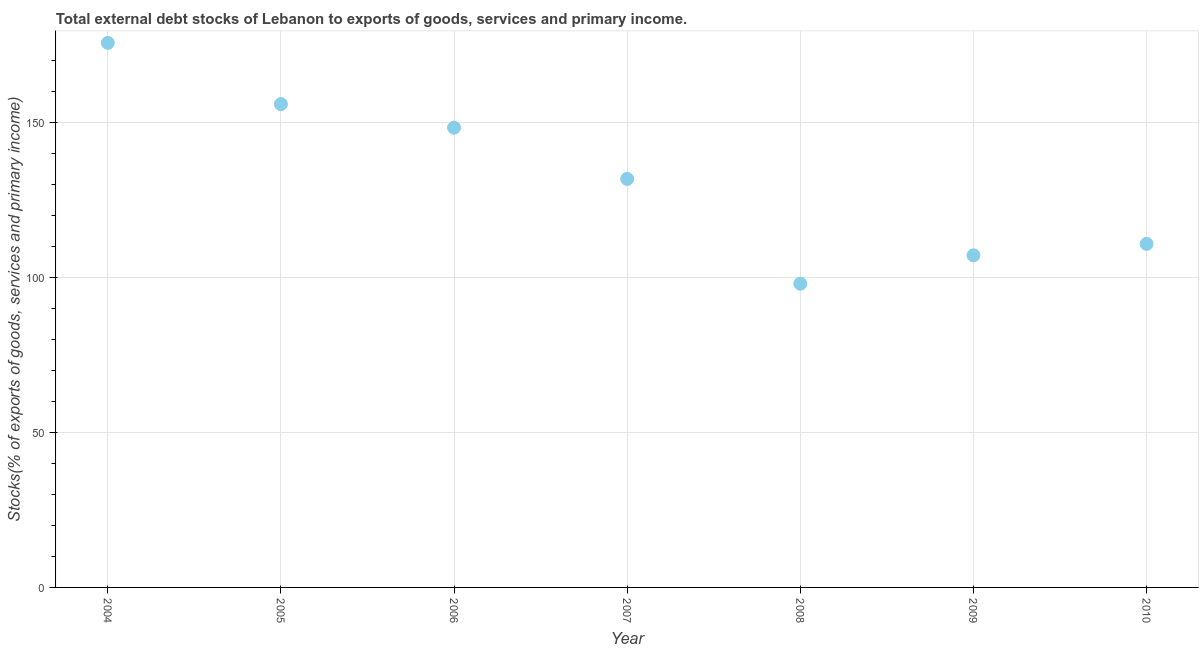What is the external debt stocks in 2007?
Your answer should be compact. 131.87. Across all years, what is the maximum external debt stocks?
Your answer should be very brief. 175.78. Across all years, what is the minimum external debt stocks?
Make the answer very short. 98.05. What is the sum of the external debt stocks?
Offer a terse response. 928.18. What is the difference between the external debt stocks in 2004 and 2010?
Keep it short and to the point. 64.89. What is the average external debt stocks per year?
Give a very brief answer. 132.6. What is the median external debt stocks?
Offer a terse response. 131.87. In how many years, is the external debt stocks greater than 90 %?
Provide a short and direct response. 7. Do a majority of the years between 2005 and 2004 (inclusive) have external debt stocks greater than 70 %?
Provide a short and direct response. No. What is the ratio of the external debt stocks in 2005 to that in 2007?
Give a very brief answer. 1.18. Is the external debt stocks in 2004 less than that in 2009?
Ensure brevity in your answer.  No. Is the difference between the external debt stocks in 2004 and 2007 greater than the difference between any two years?
Provide a succinct answer. No. What is the difference between the highest and the second highest external debt stocks?
Your answer should be compact. 19.78. What is the difference between the highest and the lowest external debt stocks?
Your answer should be very brief. 77.73. In how many years, is the external debt stocks greater than the average external debt stocks taken over all years?
Offer a terse response. 3. Does the external debt stocks monotonically increase over the years?
Ensure brevity in your answer.  No. What is the title of the graph?
Provide a succinct answer. Total external debt stocks of Lebanon to exports of goods, services and primary income. What is the label or title of the Y-axis?
Your answer should be compact. Stocks(% of exports of goods, services and primary income). What is the Stocks(% of exports of goods, services and primary income) in 2004?
Ensure brevity in your answer.  175.78. What is the Stocks(% of exports of goods, services and primary income) in 2005?
Offer a terse response. 156. What is the Stocks(% of exports of goods, services and primary income) in 2006?
Ensure brevity in your answer.  148.4. What is the Stocks(% of exports of goods, services and primary income) in 2007?
Keep it short and to the point. 131.87. What is the Stocks(% of exports of goods, services and primary income) in 2008?
Your response must be concise. 98.05. What is the Stocks(% of exports of goods, services and primary income) in 2009?
Offer a terse response. 107.2. What is the Stocks(% of exports of goods, services and primary income) in 2010?
Ensure brevity in your answer.  110.88. What is the difference between the Stocks(% of exports of goods, services and primary income) in 2004 and 2005?
Provide a succinct answer. 19.78. What is the difference between the Stocks(% of exports of goods, services and primary income) in 2004 and 2006?
Your answer should be very brief. 27.38. What is the difference between the Stocks(% of exports of goods, services and primary income) in 2004 and 2007?
Ensure brevity in your answer.  43.91. What is the difference between the Stocks(% of exports of goods, services and primary income) in 2004 and 2008?
Provide a short and direct response. 77.73. What is the difference between the Stocks(% of exports of goods, services and primary income) in 2004 and 2009?
Your answer should be compact. 68.58. What is the difference between the Stocks(% of exports of goods, services and primary income) in 2004 and 2010?
Your answer should be very brief. 64.89. What is the difference between the Stocks(% of exports of goods, services and primary income) in 2005 and 2006?
Keep it short and to the point. 7.6. What is the difference between the Stocks(% of exports of goods, services and primary income) in 2005 and 2007?
Ensure brevity in your answer.  24.13. What is the difference between the Stocks(% of exports of goods, services and primary income) in 2005 and 2008?
Provide a short and direct response. 57.95. What is the difference between the Stocks(% of exports of goods, services and primary income) in 2005 and 2009?
Your answer should be very brief. 48.8. What is the difference between the Stocks(% of exports of goods, services and primary income) in 2005 and 2010?
Your answer should be very brief. 45.11. What is the difference between the Stocks(% of exports of goods, services and primary income) in 2006 and 2007?
Make the answer very short. 16.53. What is the difference between the Stocks(% of exports of goods, services and primary income) in 2006 and 2008?
Give a very brief answer. 50.35. What is the difference between the Stocks(% of exports of goods, services and primary income) in 2006 and 2009?
Ensure brevity in your answer.  41.2. What is the difference between the Stocks(% of exports of goods, services and primary income) in 2006 and 2010?
Make the answer very short. 37.52. What is the difference between the Stocks(% of exports of goods, services and primary income) in 2007 and 2008?
Offer a terse response. 33.82. What is the difference between the Stocks(% of exports of goods, services and primary income) in 2007 and 2009?
Make the answer very short. 24.67. What is the difference between the Stocks(% of exports of goods, services and primary income) in 2007 and 2010?
Give a very brief answer. 20.99. What is the difference between the Stocks(% of exports of goods, services and primary income) in 2008 and 2009?
Your response must be concise. -9.15. What is the difference between the Stocks(% of exports of goods, services and primary income) in 2008 and 2010?
Your answer should be very brief. -12.84. What is the difference between the Stocks(% of exports of goods, services and primary income) in 2009 and 2010?
Provide a short and direct response. -3.68. What is the ratio of the Stocks(% of exports of goods, services and primary income) in 2004 to that in 2005?
Give a very brief answer. 1.13. What is the ratio of the Stocks(% of exports of goods, services and primary income) in 2004 to that in 2006?
Ensure brevity in your answer.  1.18. What is the ratio of the Stocks(% of exports of goods, services and primary income) in 2004 to that in 2007?
Ensure brevity in your answer.  1.33. What is the ratio of the Stocks(% of exports of goods, services and primary income) in 2004 to that in 2008?
Your answer should be very brief. 1.79. What is the ratio of the Stocks(% of exports of goods, services and primary income) in 2004 to that in 2009?
Ensure brevity in your answer.  1.64. What is the ratio of the Stocks(% of exports of goods, services and primary income) in 2004 to that in 2010?
Offer a very short reply. 1.58. What is the ratio of the Stocks(% of exports of goods, services and primary income) in 2005 to that in 2006?
Make the answer very short. 1.05. What is the ratio of the Stocks(% of exports of goods, services and primary income) in 2005 to that in 2007?
Offer a very short reply. 1.18. What is the ratio of the Stocks(% of exports of goods, services and primary income) in 2005 to that in 2008?
Offer a very short reply. 1.59. What is the ratio of the Stocks(% of exports of goods, services and primary income) in 2005 to that in 2009?
Provide a succinct answer. 1.46. What is the ratio of the Stocks(% of exports of goods, services and primary income) in 2005 to that in 2010?
Offer a terse response. 1.41. What is the ratio of the Stocks(% of exports of goods, services and primary income) in 2006 to that in 2007?
Provide a succinct answer. 1.12. What is the ratio of the Stocks(% of exports of goods, services and primary income) in 2006 to that in 2008?
Provide a short and direct response. 1.51. What is the ratio of the Stocks(% of exports of goods, services and primary income) in 2006 to that in 2009?
Provide a short and direct response. 1.38. What is the ratio of the Stocks(% of exports of goods, services and primary income) in 2006 to that in 2010?
Give a very brief answer. 1.34. What is the ratio of the Stocks(% of exports of goods, services and primary income) in 2007 to that in 2008?
Give a very brief answer. 1.34. What is the ratio of the Stocks(% of exports of goods, services and primary income) in 2007 to that in 2009?
Provide a short and direct response. 1.23. What is the ratio of the Stocks(% of exports of goods, services and primary income) in 2007 to that in 2010?
Offer a terse response. 1.19. What is the ratio of the Stocks(% of exports of goods, services and primary income) in 2008 to that in 2009?
Ensure brevity in your answer.  0.92. What is the ratio of the Stocks(% of exports of goods, services and primary income) in 2008 to that in 2010?
Your response must be concise. 0.88. What is the ratio of the Stocks(% of exports of goods, services and primary income) in 2009 to that in 2010?
Your answer should be compact. 0.97. 